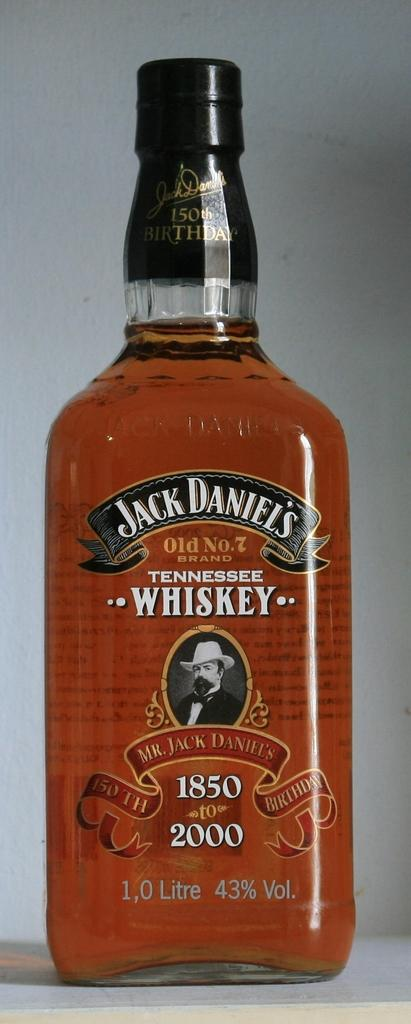<image>
Describe the image concisely. A bottle of Jack Daniel's Tennessee whiskey which started in 1850. 